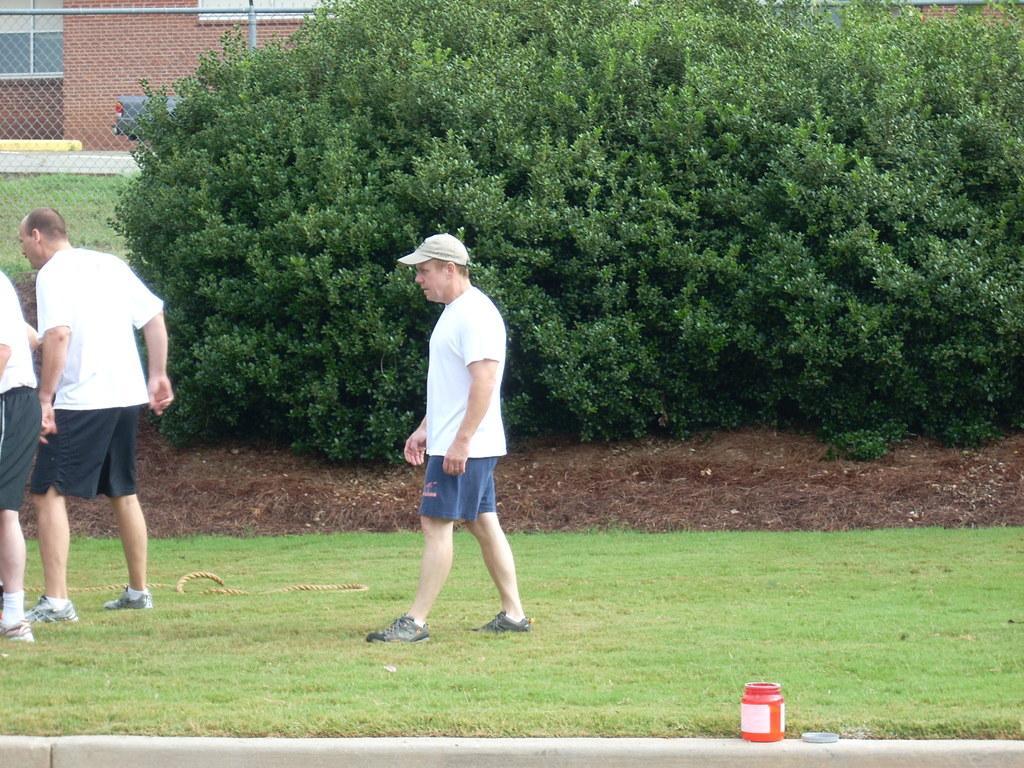Please provide a concise description of this image. In this picture there are men in the image, on the grassland and there is a building and net boundary in the background area of the image, there is greenery in the image. 